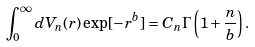Convert formula to latex. <formula><loc_0><loc_0><loc_500><loc_500>\int _ { 0 } ^ { \infty } d V _ { n } ( r ) \exp [ - r ^ { b } ] = C _ { n } \Gamma \left ( 1 + \frac { n } { b } \right ) .</formula> 